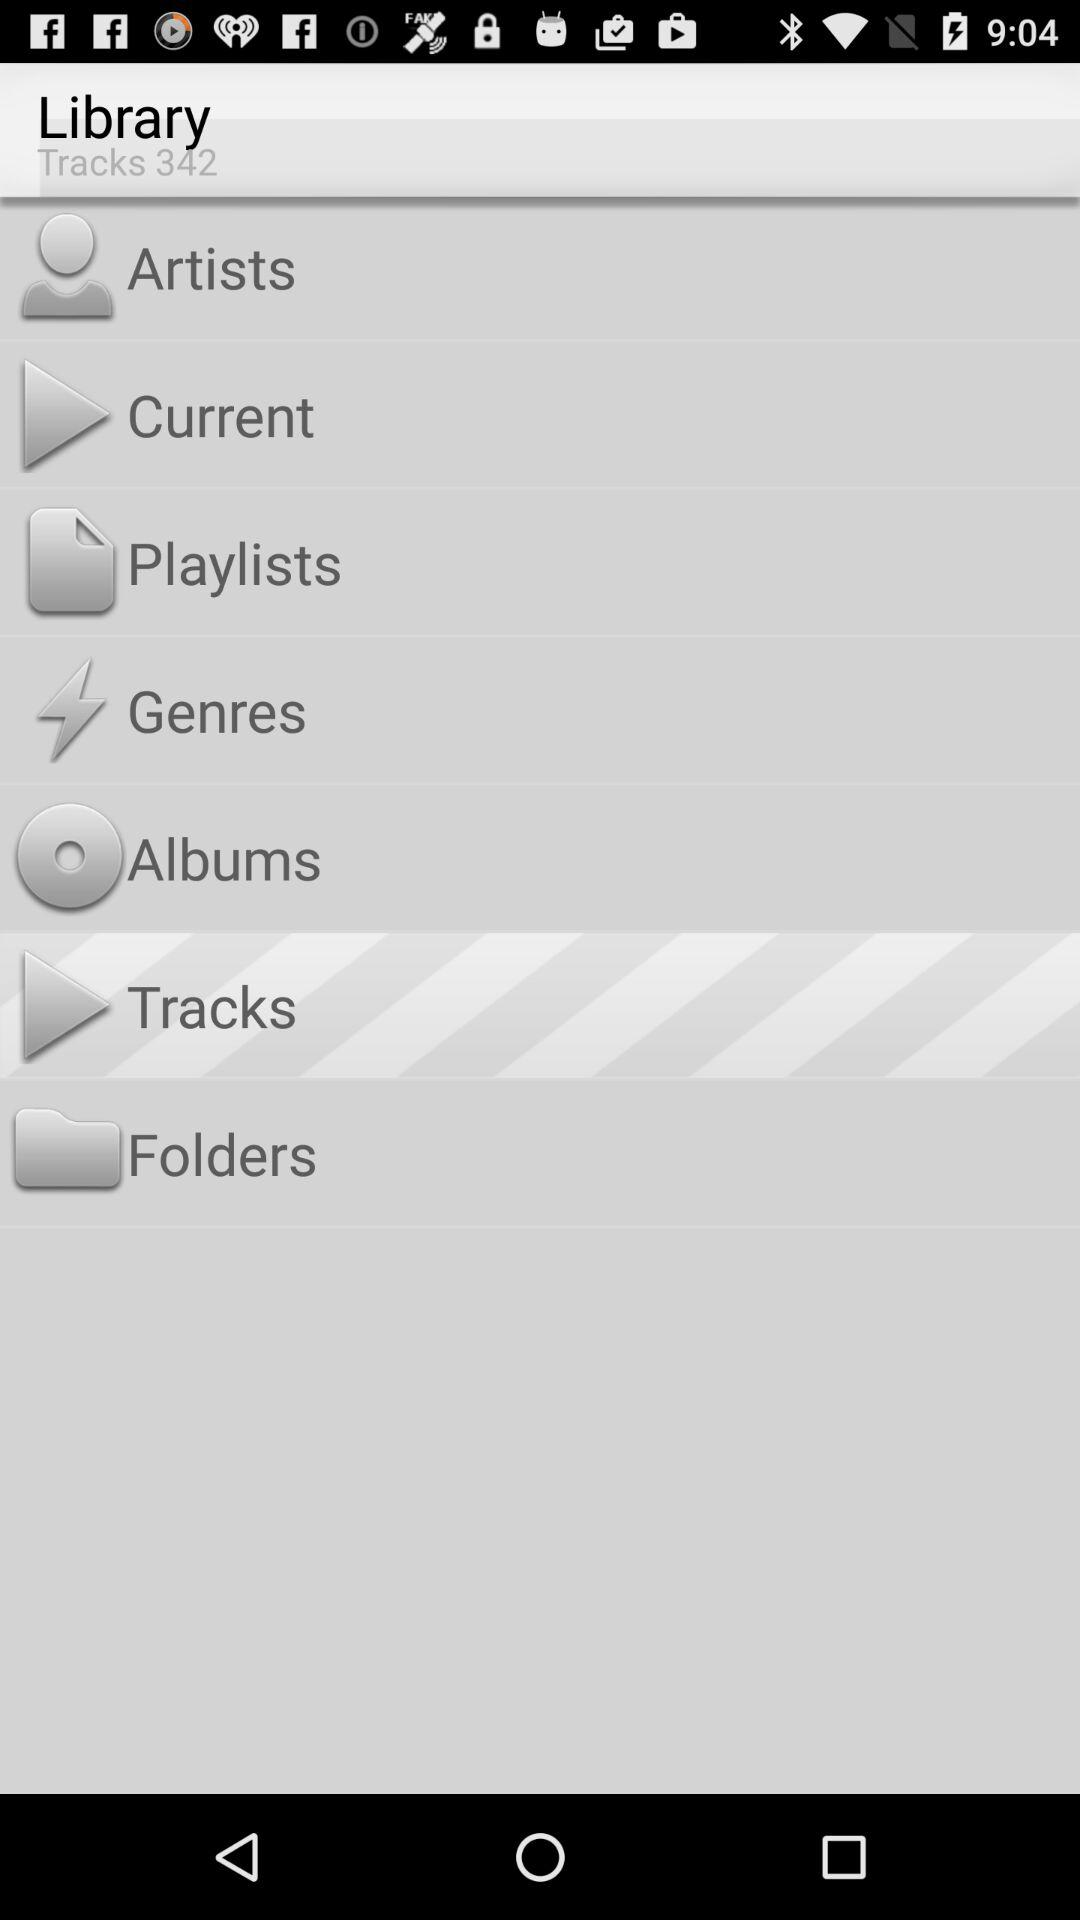How many tracks are there? There are 342 tracks. 